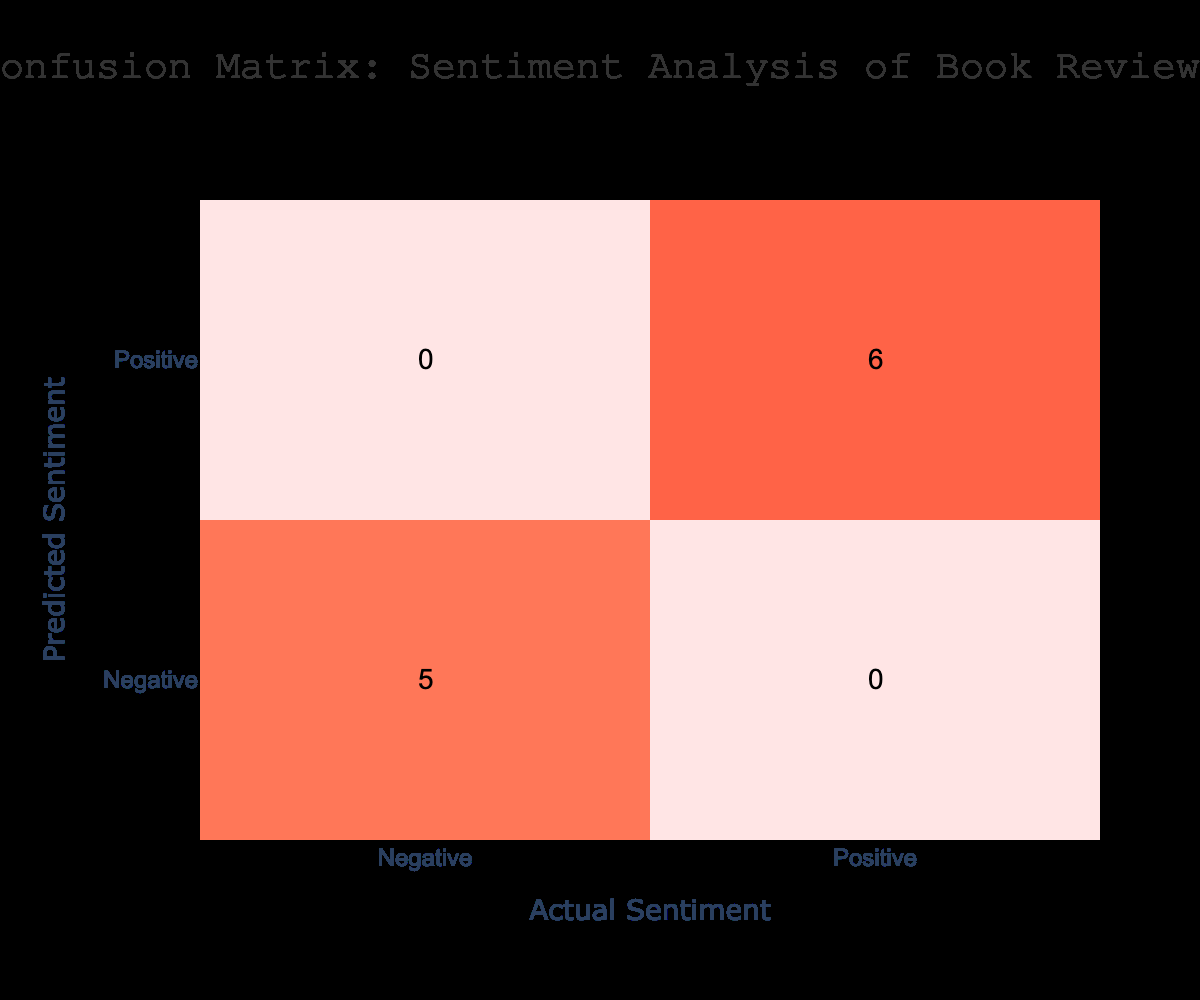What is the number of positive reviews? The table indicates the counts of reviews categorized by sentiment, where the entry under "Positive" sentiment indicates 6 reviews.
Answer: 6 What is the number of negative reviews? Similarly, the count of negative reviews can be found in the table under the "Negative" sentiment entry, which shows 4 reviews.
Answer: 4 How many true positives are there? True positives refer to reviews that were predicted as positive and are also actually positive. From the table, we see that there are 6 such instances in the "Positive" row and "Positive" column intersection.
Answer: 6 How many false negatives are there? False negatives are cases where the actual sentiment is positive, but it was predicted as negative. The confusion matrix shows there are no values in the "Negative" predicted row that correspond to the "Positive" actual column, which means 0 false negatives.
Answer: 0 What is the total count of reviews in the table? To find the total number of reviews, we simply add the counts of all the entries in the confusion matrix: 6 positive + 0 false negatives + 0 false positives + 4 negative = 10.
Answer: 10 Are there any false positives? False positives are cases where the actual sentiment is negative, but they were predicted as positive. Referring to the table, we see there are no counts observed in the confusion matrix at the "Positive" predicted row corresponding to the "Negative" actual column, so the answer is no.
Answer: No What percentage of reviews were predicted correctly? To find the percentage of correctly predicted reviews, we compute the sum of true positives (6) and true negatives (4), and divide that by the total reviews (10): (6 + 4) / 10 * 100 = 100%.
Answer: 100% If a review is predicted as negative, what is the probability that it is actually negative? This is found by looking for the value in the confusion matrix at the intersection of predicted negative and actual negative (4) and dividing it by the total predicted negative reviews (4). Thus, 4 / 4 = 1.
Answer: 1 What is the difference between the number of predicted positive reviews and actual positive reviews? The actual count of positive reviews is 6, and the sum of predicted positive (also 6) leads to a difference of 6 - 6 = 0.
Answer: 0 